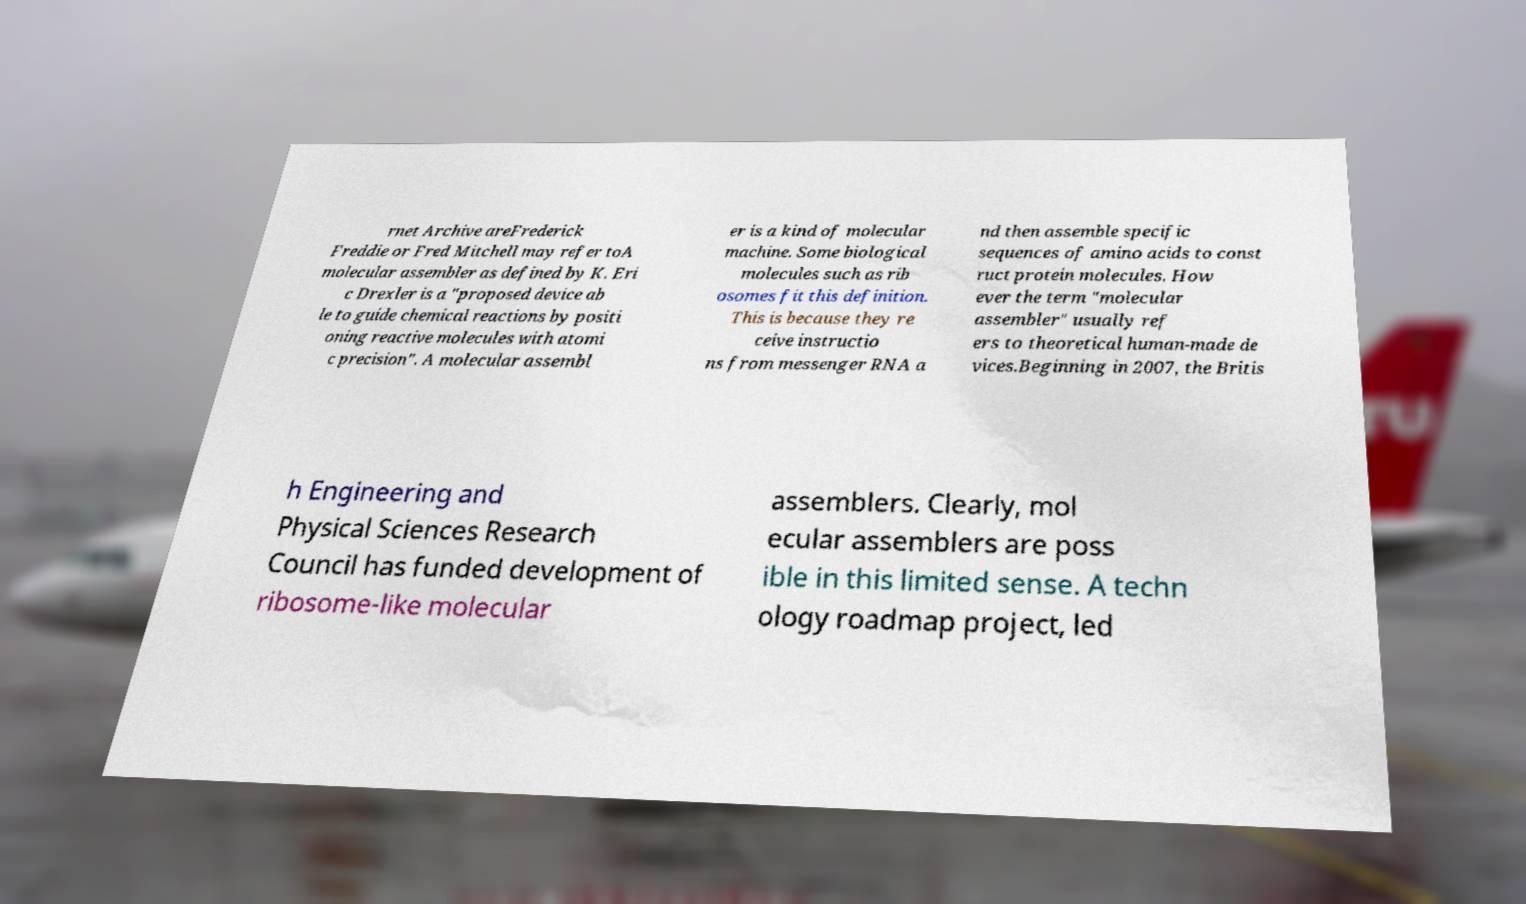Can you read and provide the text displayed in the image?This photo seems to have some interesting text. Can you extract and type it out for me? rnet Archive areFrederick Freddie or Fred Mitchell may refer toA molecular assembler as defined by K. Eri c Drexler is a "proposed device ab le to guide chemical reactions by positi oning reactive molecules with atomi c precision". A molecular assembl er is a kind of molecular machine. Some biological molecules such as rib osomes fit this definition. This is because they re ceive instructio ns from messenger RNA a nd then assemble specific sequences of amino acids to const ruct protein molecules. How ever the term "molecular assembler" usually ref ers to theoretical human-made de vices.Beginning in 2007, the Britis h Engineering and Physical Sciences Research Council has funded development of ribosome-like molecular assemblers. Clearly, mol ecular assemblers are poss ible in this limited sense. A techn ology roadmap project, led 